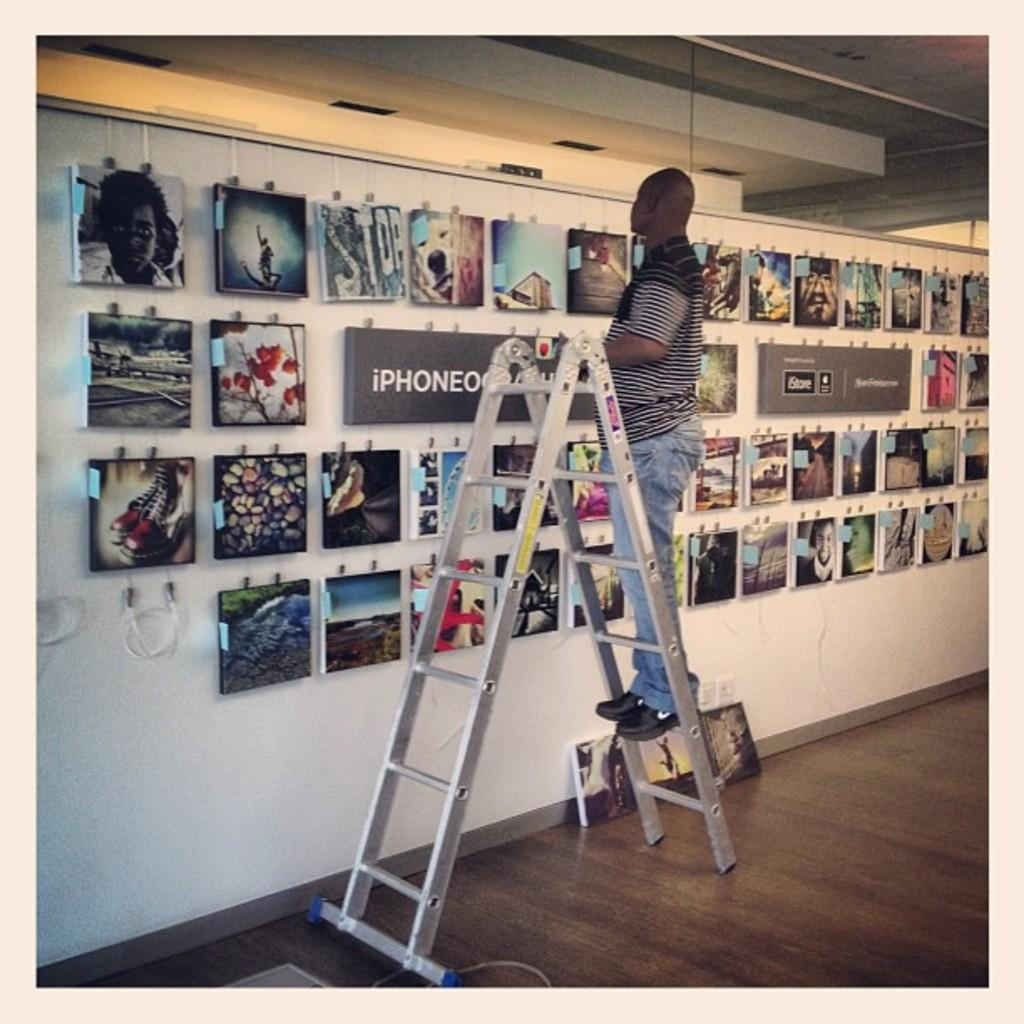<image>
Summarize the visual content of the image. A man stands on a ladder with the word iphone on a wall in front of him 